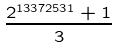<formula> <loc_0><loc_0><loc_500><loc_500>\frac { 2 ^ { 1 3 3 7 2 5 3 1 } + 1 } { 3 }</formula> 